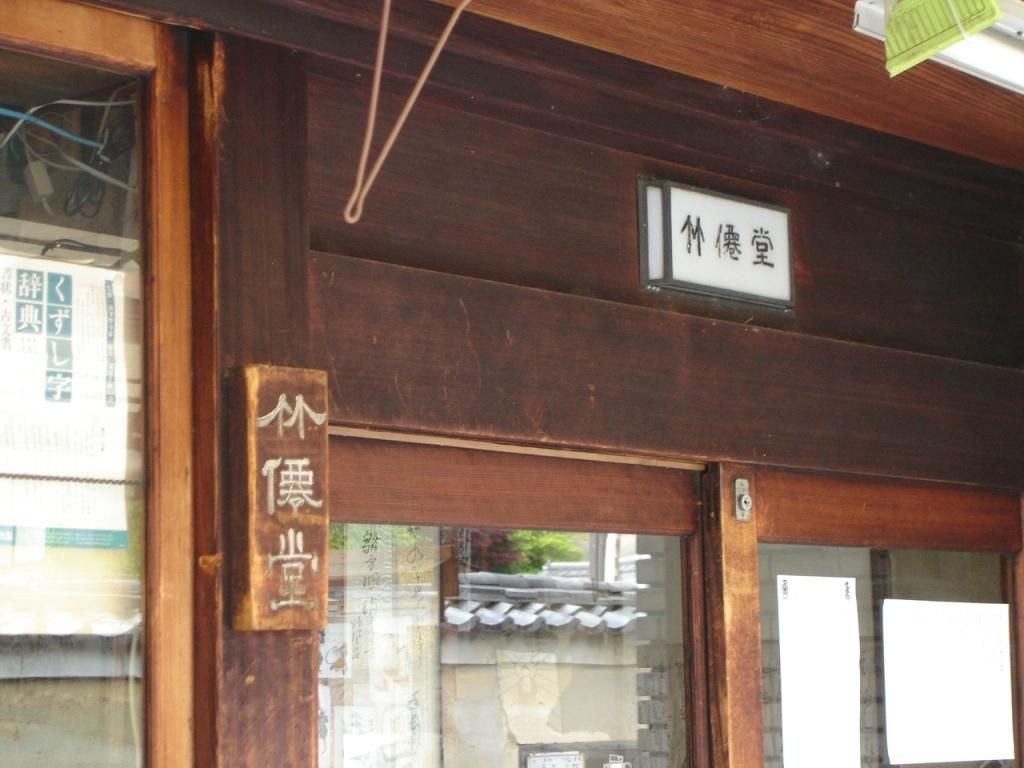What is a prominent feature in the image? The image contains a door. What material is the door made of? The door is made of wood. Is there any other opening visible in the image? Yes, there is a window on the left side of the door. Can you see a patch on the door in the image? There is no patch visible on the door in the image. 